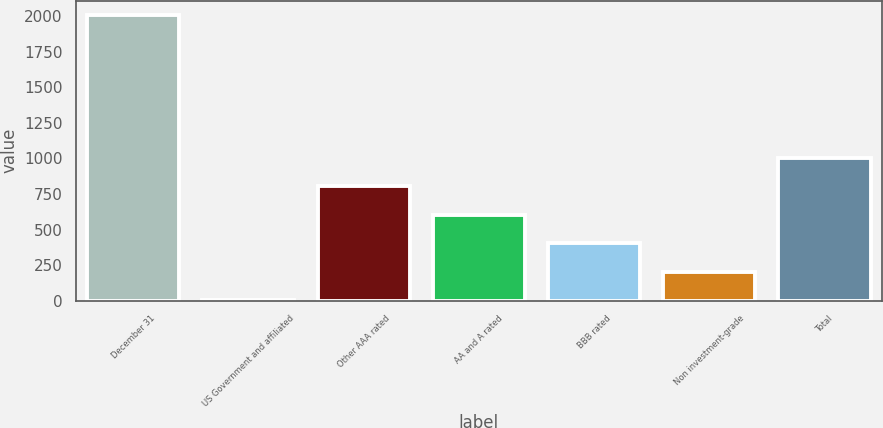Convert chart to OTSL. <chart><loc_0><loc_0><loc_500><loc_500><bar_chart><fcel>December 31<fcel>US Government and affiliated<fcel>Other AAA rated<fcel>AA and A rated<fcel>BBB rated<fcel>Non investment-grade<fcel>Total<nl><fcel>2007<fcel>2.5<fcel>804.3<fcel>603.85<fcel>403.4<fcel>202.95<fcel>1004.75<nl></chart> 